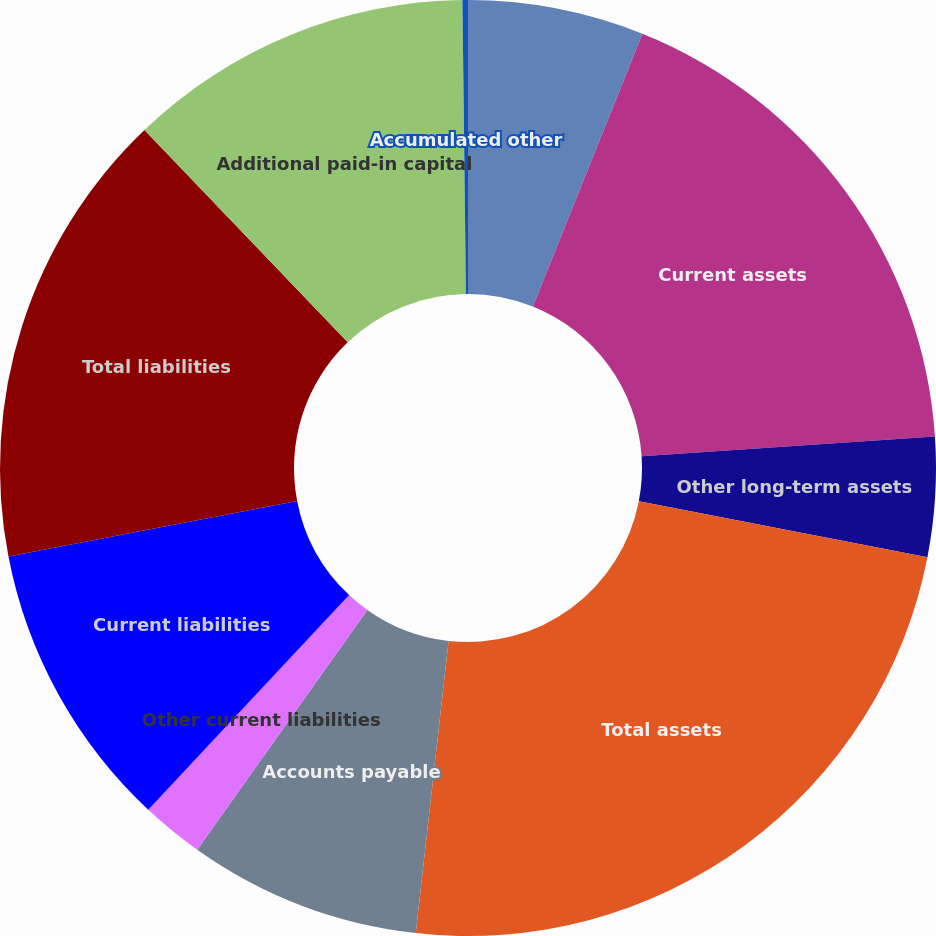Convert chart. <chart><loc_0><loc_0><loc_500><loc_500><pie_chart><fcel>Accounts receivable<fcel>Current assets<fcel>Other long-term assets<fcel>Total assets<fcel>Accounts payable<fcel>Other current liabilities<fcel>Current liabilities<fcel>Total liabilities<fcel>Additional paid-in capital<fcel>Accumulated other<nl><fcel>6.08%<fcel>17.85%<fcel>4.12%<fcel>23.73%<fcel>8.04%<fcel>2.15%<fcel>10.0%<fcel>15.88%<fcel>11.96%<fcel>0.19%<nl></chart> 